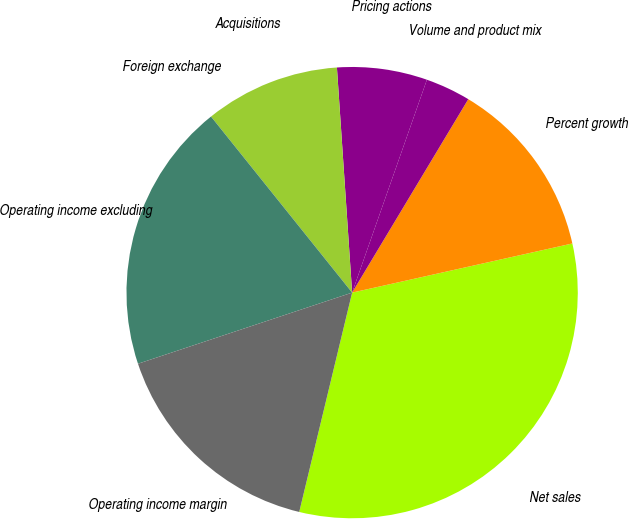<chart> <loc_0><loc_0><loc_500><loc_500><pie_chart><fcel>Net sales<fcel>Percent growth<fcel>Volume and product mix<fcel>Pricing actions<fcel>Acquisitions<fcel>Foreign exchange<fcel>Operating income excluding<fcel>Operating income margin<nl><fcel>32.26%<fcel>12.9%<fcel>3.23%<fcel>6.45%<fcel>9.68%<fcel>0.0%<fcel>19.35%<fcel>16.13%<nl></chart> 